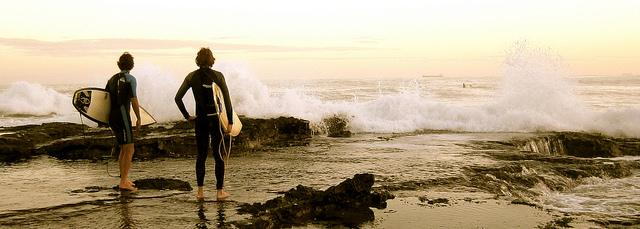Why are the surfer's hesitant to surf here?

Choices:
A) huge waves
B) rocks
C) small waves
D) cold water rocks 